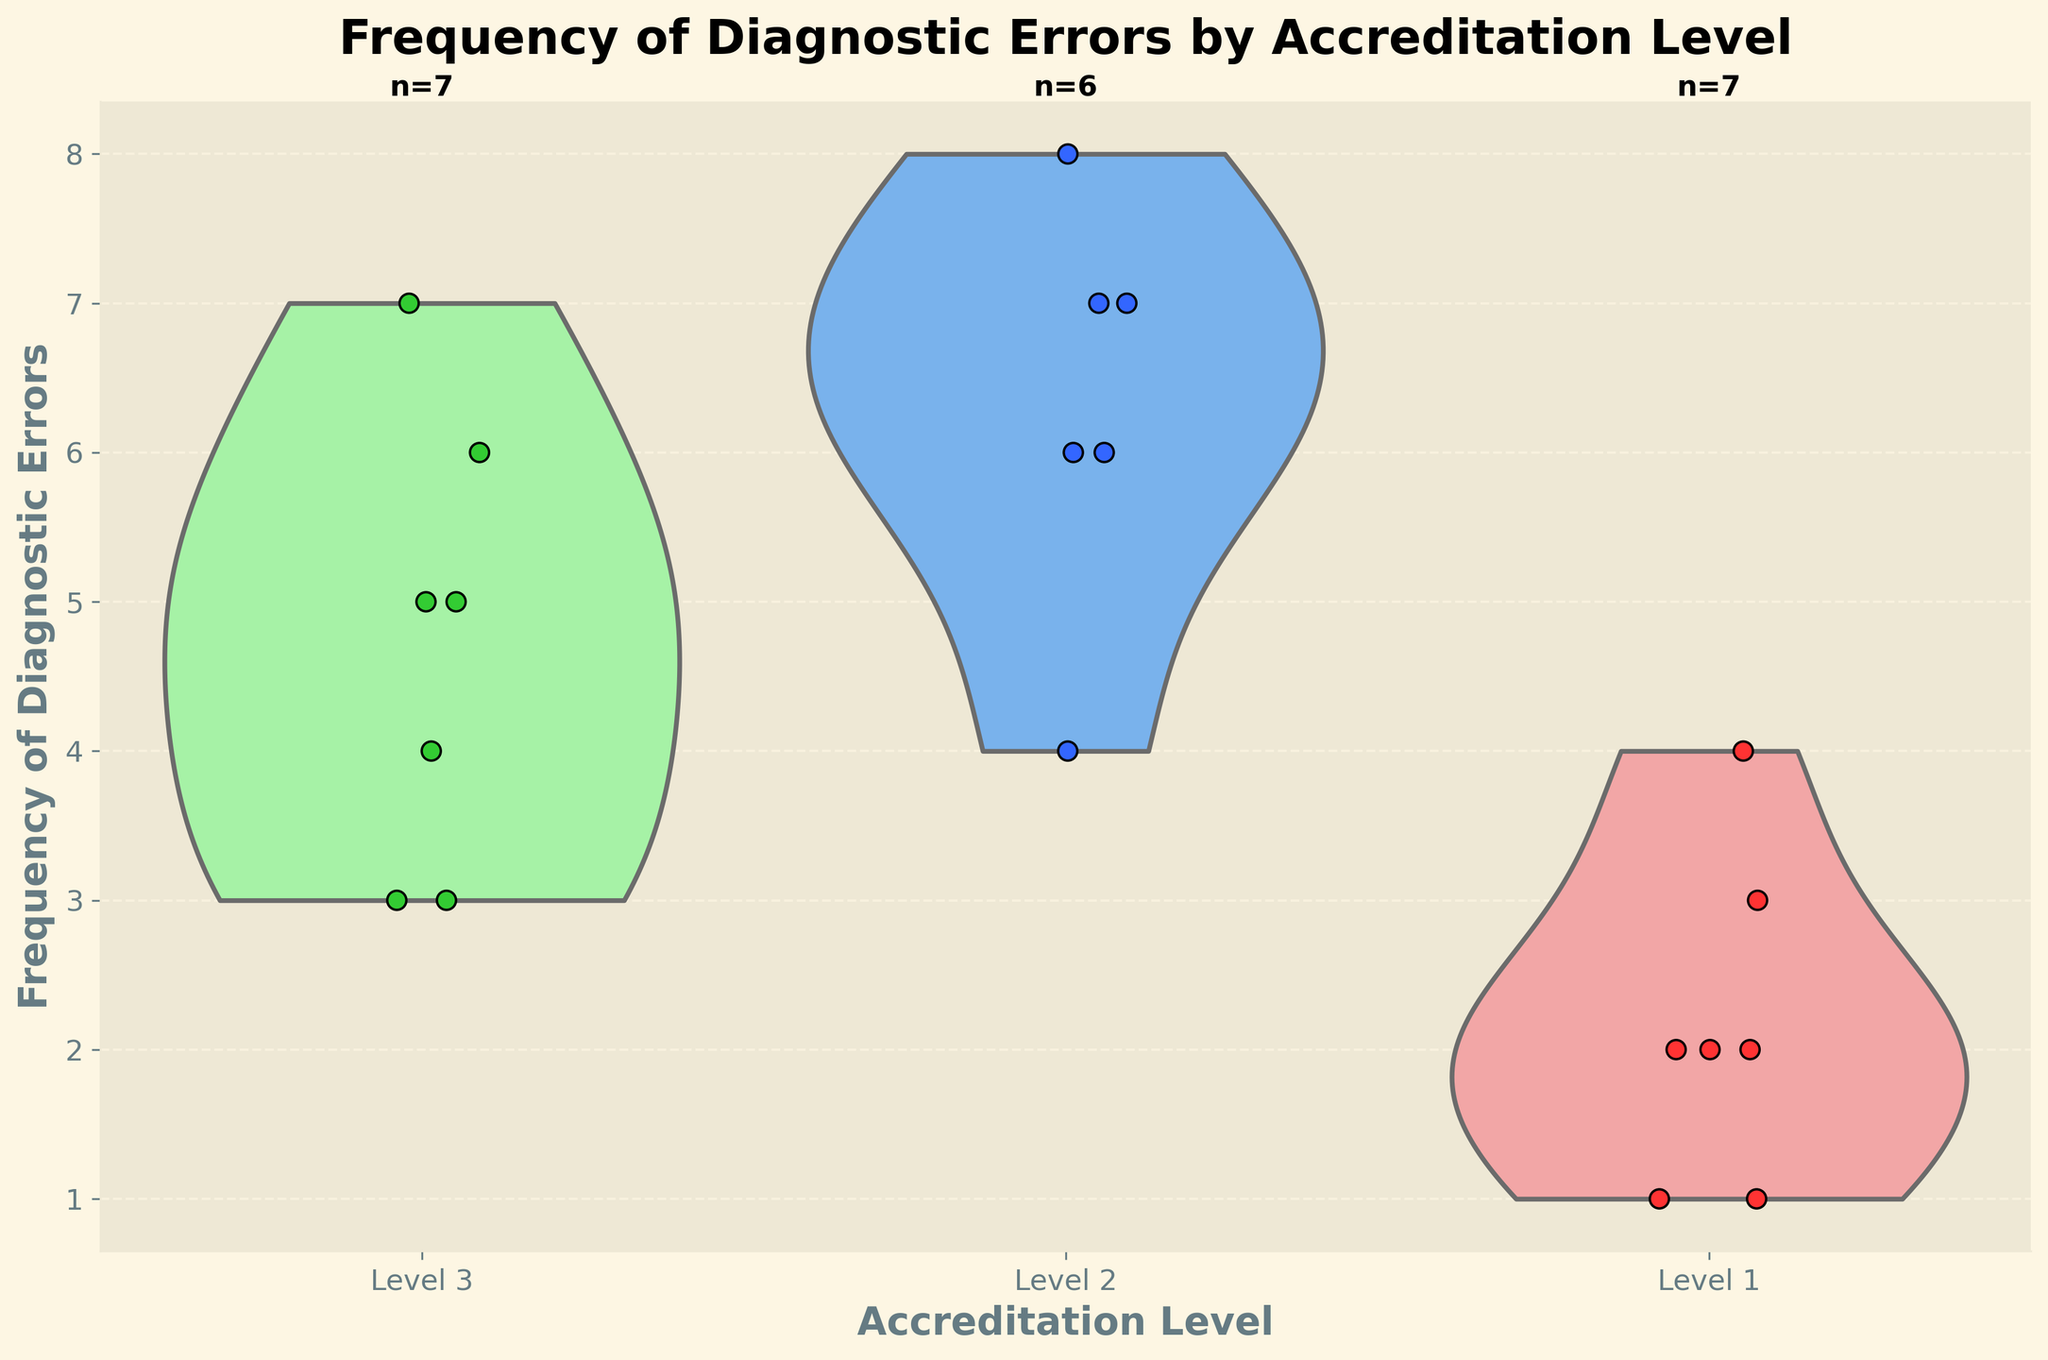What's the title of the figure? The title of the figure is prominently displayed at the top. It provides a summary of the data being visualized.
Answer: Frequency of Diagnostic Errors by Accreditation Level What are the x-axis labels? The x-axis labels represent the different accreditation levels of health facilities shown in the figure. They are located at the bottom of the chart.
Answer: Level 1, Level 2, Level 3 What is the maximum value of the y-axis? By looking at the y-axis, which shows the frequency of diagnostic errors, the highest number displayed can be identified.
Answer: 8 How many data points are there for Accreditation Level 3? Each violin plot has a number indicating the count of data points. For Level 3, the count can be read from the text above the violin plot.
Answer: 6 Which Accreditation Level has the highest median frequency of diagnostic errors? The median of each group can be estimated by looking at the distribution shape of the violin plot. The median is typically located around the middle of the thickest part of the distribution.
Answer: Level 2 Which Accreditation Level shows the widest range of diagnostic error frequencies? The range for each level is indicated by the width and height of the violin plot. The widest range can be seen by comparing the span of each violin plot along the y-axis.
Answer: Level 2 How many different colors are used to represent the jittered points for each Accreditation Level? The different colors of the jittered points for each accreditation level are distinguishable. Each level corresponds to a unique color.
Answer: 3 For Accreditation Level 1, what is the highest number of diagnostic errors observed? The highest data point within the jittered points can be noted by observing the uppermost point within Level 1's distribution.
Answer: 4 Which Accreditation Level has the lowest frequency of diagnostic errors as a whole? The lowest value in each group can be identified by observing the bottom of the violin plots and jittered points.
Answer: Level 1 Is there any Accreditation Level where the frequency of diagnostic errors reaches the extreme observed value of 8? By examining the violin plots and corresponding jittered points, it is possible to determine if any of the accreditation levels reach the value of 8.
Answer: Level 2 